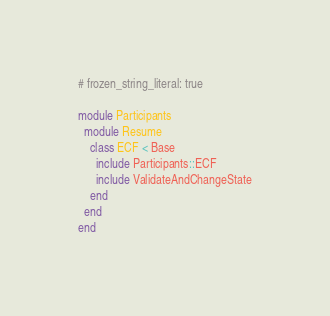<code> <loc_0><loc_0><loc_500><loc_500><_Ruby_># frozen_string_literal: true

module Participants
  module Resume
    class ECF < Base
      include Participants::ECF
      include ValidateAndChangeState
    end
  end
end
</code> 